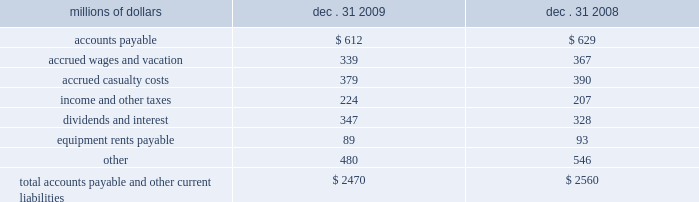Unusual , ( ii ) is material in amount , and ( iii ) varies significantly from the retirement profile identified through our depreciation studies .
A gain or loss is recognized in other income when we sell land or dispose of assets that are not part of our railroad operations .
When we purchase an asset , we capitalize all costs necessary to make the asset ready for its intended use .
However , many of our assets are self-constructed .
A large portion of our capital expenditures is for replacement of existing road infrastructure assets ( program projects ) , which is typically performed by our employees , and for track line expansion ( capacity projects ) .
Costs that are directly attributable or overhead costs that relate directly to capital projects are capitalized .
Direct costs that are capitalized as part of self-constructed assets include material , labor , and work equipment .
Indirect costs are capitalized if they clearly relate to the construction of the asset .
These costs are allocated using appropriate statistical bases .
General and administrative expenditures are expensed as incurred .
Normal repairs and maintenance are also expensed as incurred , while costs incurred that extend the useful life of an asset , improve the safety of our operations or improve operating efficiency are capitalized .
Assets held under capital leases are recorded at the lower of the net present value of the minimum lease payments or the fair value of the leased asset at the inception of the lease .
Amortization expense is computed using the straight-line method over the shorter of the estimated useful lives of the assets or the period of the related lease .
11 .
Accounts payable and other current liabilities dec .
31 , dec .
31 , millions of dollars 2009 2008 .
12 .
Financial instruments strategy and risk 2013 we may use derivative financial instruments in limited instances for other than trading purposes to assist in managing our overall exposure to fluctuations in interest rates and fuel prices .
We are not a party to leveraged derivatives and , by policy , do not use derivative financial instruments for speculative purposes .
Derivative financial instruments qualifying for hedge accounting must maintain a specified level of effectiveness between the hedging instrument and the item being hedged , both at inception and throughout the hedged period .
We formally document the nature and relationships between the hedging instruments and hedged items at inception , as well as our risk-management objectives , strategies for undertaking the various hedge transactions , and method of assessing hedge effectiveness .
Changes in the fair market value of derivative financial instruments that do not qualify for hedge accounting are charged to earnings .
We may use swaps , collars , futures , and/or forward contracts to mitigate the risk of adverse movements in interest rates and fuel prices ; however , the use of these derivative financial instruments may limit future benefits from favorable interest rate and fuel price movements. .
What was the percentage increase in short term debt for amounts distributed to shareholders and debt holders during 2009? 
Computations: ((347 - 328) / 328)
Answer: 0.05793. 